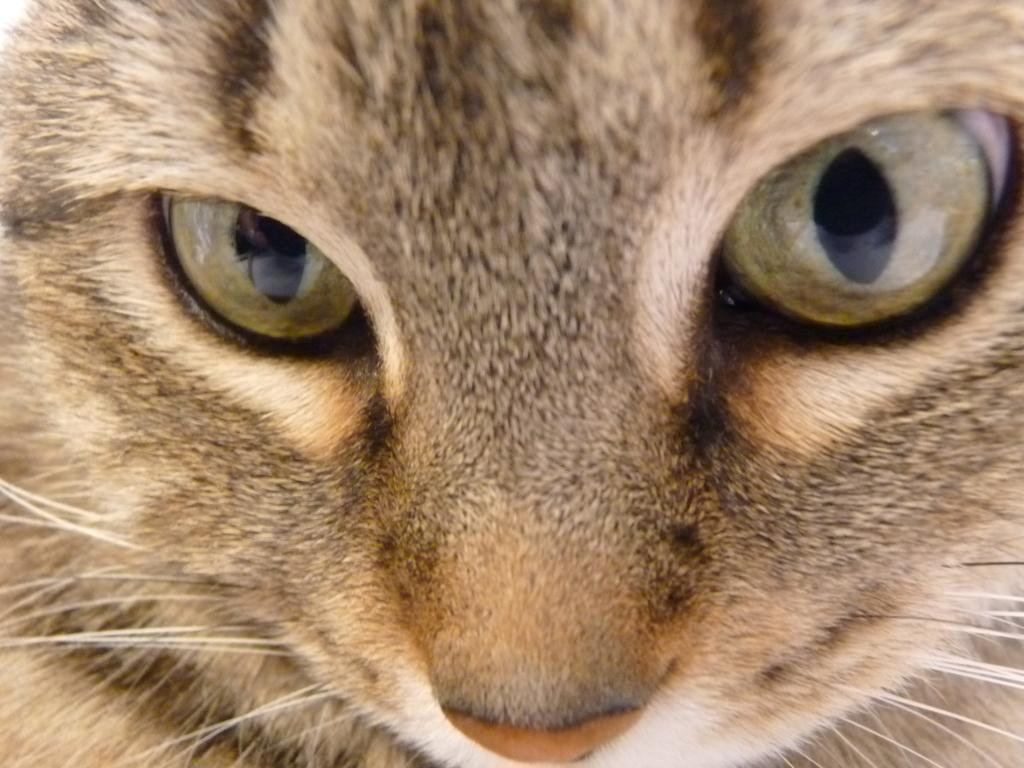What type of image features an animal face? The image features an animal face. What are the main features of the animal face? The animal face has eyes and a nose. What is the chance of winning a prize at the cemetery depicted in the image? There is no cemetery depicted in the image, and therefore no chance of winning a prize can be determined. 